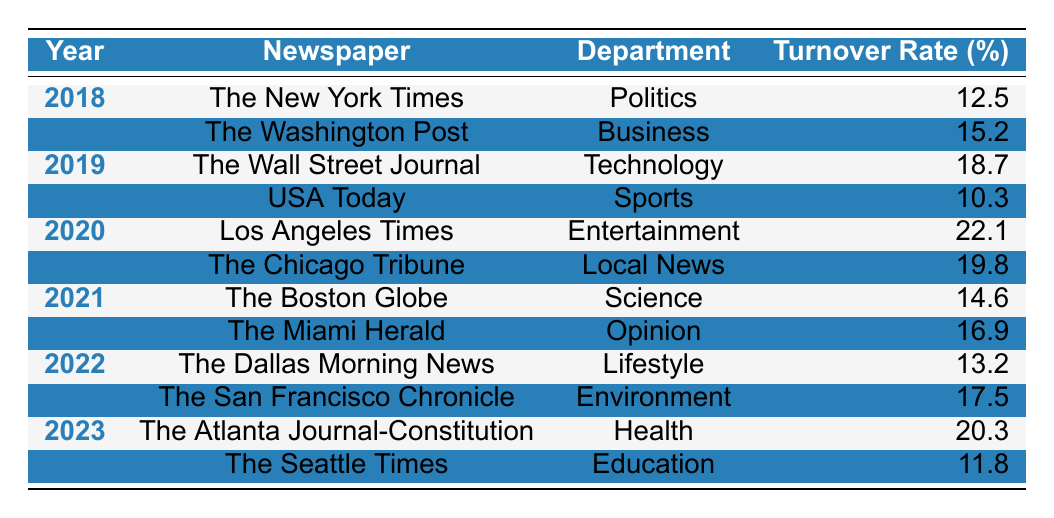What was the turnover rate for The Washington Post in 2018? The table lists the turnover rate for The Washington Post in 2018 as 15.2%.
Answer: 15.2 Which newspaper had the highest turnover rate in 2020? The table shows that Los Angeles Times had the highest turnover rate for 2020 at 22.1%.
Answer: Los Angeles Times What is the average turnover rate for the Politics department across all years? The turnover rates for the Politics department are from The New York Times in 2018, which is 12.5%. Since this is the only entry for this department, the average is simply 12.5%.
Answer: 12.5 Is the turnover rate for The Dallas Morning News greater than the average turnover rate of The Miami Herald and The Boston Globe in 2021? The turnover rate for The Dallas Morning News is 13.2%. The turnover rates for The Miami Herald and The Boston Globe are 16.9% and 14.6%, respectively, with an average of (16.9 + 14.6) / 2 = 15.75%. Since 13.2% is less than 15.75%, the statement is false.
Answer: No What was the turnover rate change for USA Today from 2019 to 2023? USA Today's turnover rate in 2019 was 10.3%. The table does not provide a turnover rate for USA Today in 2023, which means we cannot determine the change. Therefore, it is not applicable.
Answer: Not applicable Which year saw the least turnover rate and what is the rate? By looking through the years, the least turnover rate is 10.3%, recorded in 2019 by USA Today.
Answer: 10.3 How does the turnover rate of The Seattle Times in 2023 compare to the turnover rate of The Chicago Tribune in 2020? The Seattle Times turnover rate in 2023 is 11.8%, while The Chicago Tribune had a rate of 19.8% in 2020. 11.8% is less than 19.8%, so it is lower.
Answer: Lower What is the total turnover rate for the Environment department for the years 2022 and 2023? The turnover rate for the Environment department in 2022 is 17.5% (San Francisco Chronicle), and since there is no entry for it in 2023, we only consider the 2022 rate for the total, which remains 17.5%.
Answer: 17.5 How many newspapers reported turnover rates of over 15% in 2021? In 2021, The Miami Herald (16.9%) and The Boston Globe (14.6%) are the two entries. However, 14.6% does not exceed 15%, so only one newspaper exceeds 15%.
Answer: 1 Which department had the highest turnover rate overall from 2018 to 2023? The department with the highest turnover rate is Entertainment from the Los Angeles Times in 2020 with a rate of 22.1%.
Answer: Entertainment Is it true that the turnover rate increased each year from 2018 to 2023? Reviewing the table shows fluctuations in turnover rates: 12.5% (2018), 15.2% (2018), 10.3% (2019), 18.7% (2019), 22.1% (2020), 19.8% (2020), 14.6% (2021), 16.9% (2021), 13.2% (2022), 17.5% (2022), 20.3% (2023), and 11.8% (2023). Since there are decreases, this statement is false.
Answer: False 